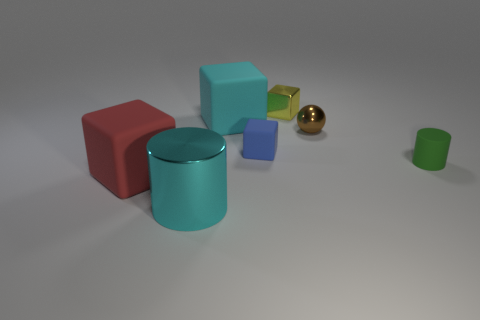The small brown shiny object has what shape?
Make the answer very short. Sphere. How many tiny blue rubber objects have the same shape as the large cyan shiny thing?
Provide a succinct answer. 0. How many blocks are left of the small blue object and behind the tiny green thing?
Give a very brief answer. 1. What is the color of the tiny rubber block?
Your response must be concise. Blue. Is there a large yellow cylinder that has the same material as the tiny sphere?
Your response must be concise. No. Is there a thing that is to the left of the small yellow cube right of the large rubber cube behind the red cube?
Offer a very short reply. Yes. Are there any large objects in front of the green matte thing?
Your answer should be compact. Yes. Are there any matte objects of the same color as the big cylinder?
Your answer should be compact. Yes. How many large things are either yellow shiny things or red rubber blocks?
Provide a succinct answer. 1. Do the big red cube to the left of the small green rubber object and the blue block have the same material?
Offer a very short reply. Yes. 